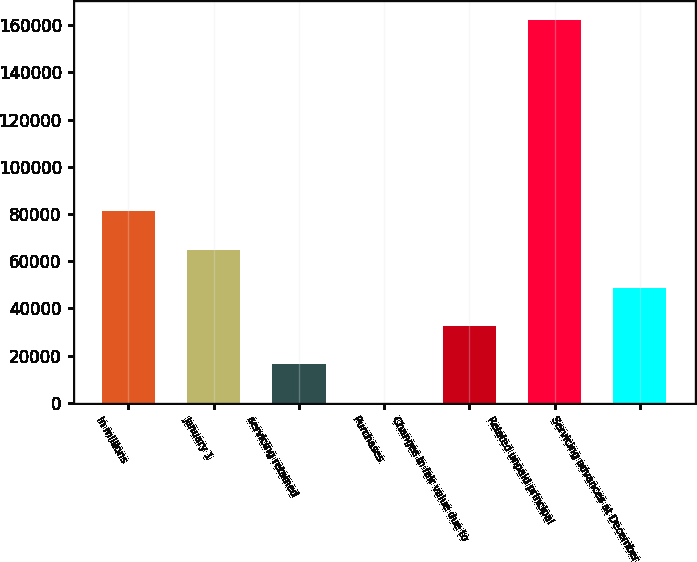Convert chart. <chart><loc_0><loc_0><loc_500><loc_500><bar_chart><fcel>In millions<fcel>January 1<fcel>servicing retained<fcel>Purchases<fcel>Changes in fair value due to<fcel>Related unpaid principal<fcel>Servicing advances at December<nl><fcel>81125.5<fcel>64914.2<fcel>16280.3<fcel>69<fcel>32491.6<fcel>162182<fcel>48702.9<nl></chart> 